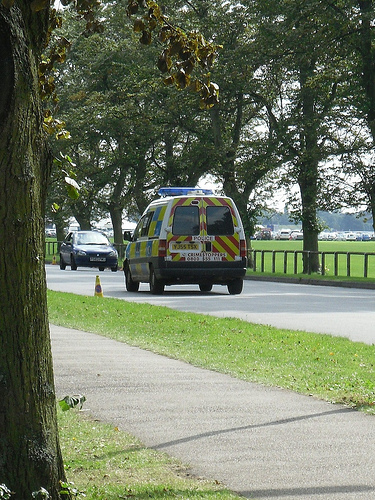<image>
Can you confirm if the car is on the road? Yes. Looking at the image, I can see the car is positioned on top of the road, with the road providing support. 